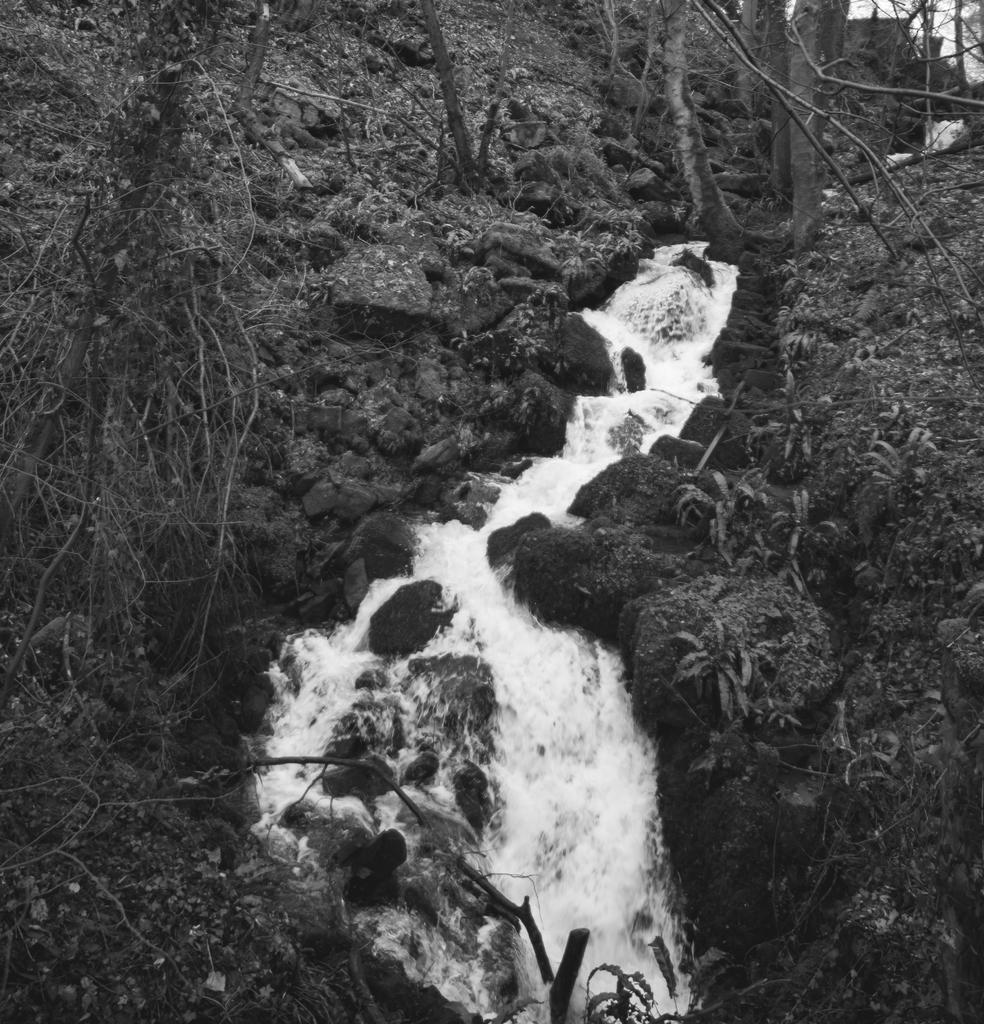Describe this image in one or two sentences. In the center of the image we can see a waterfall. In the background there are trees. 